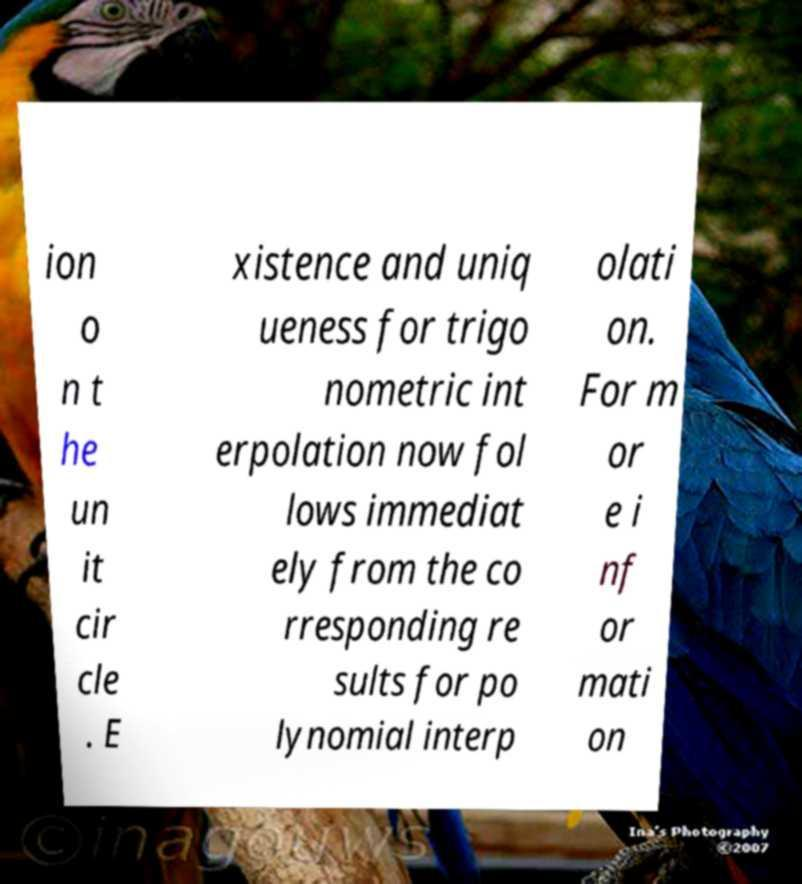There's text embedded in this image that I need extracted. Can you transcribe it verbatim? ion o n t he un it cir cle . E xistence and uniq ueness for trigo nometric int erpolation now fol lows immediat ely from the co rresponding re sults for po lynomial interp olati on. For m or e i nf or mati on 